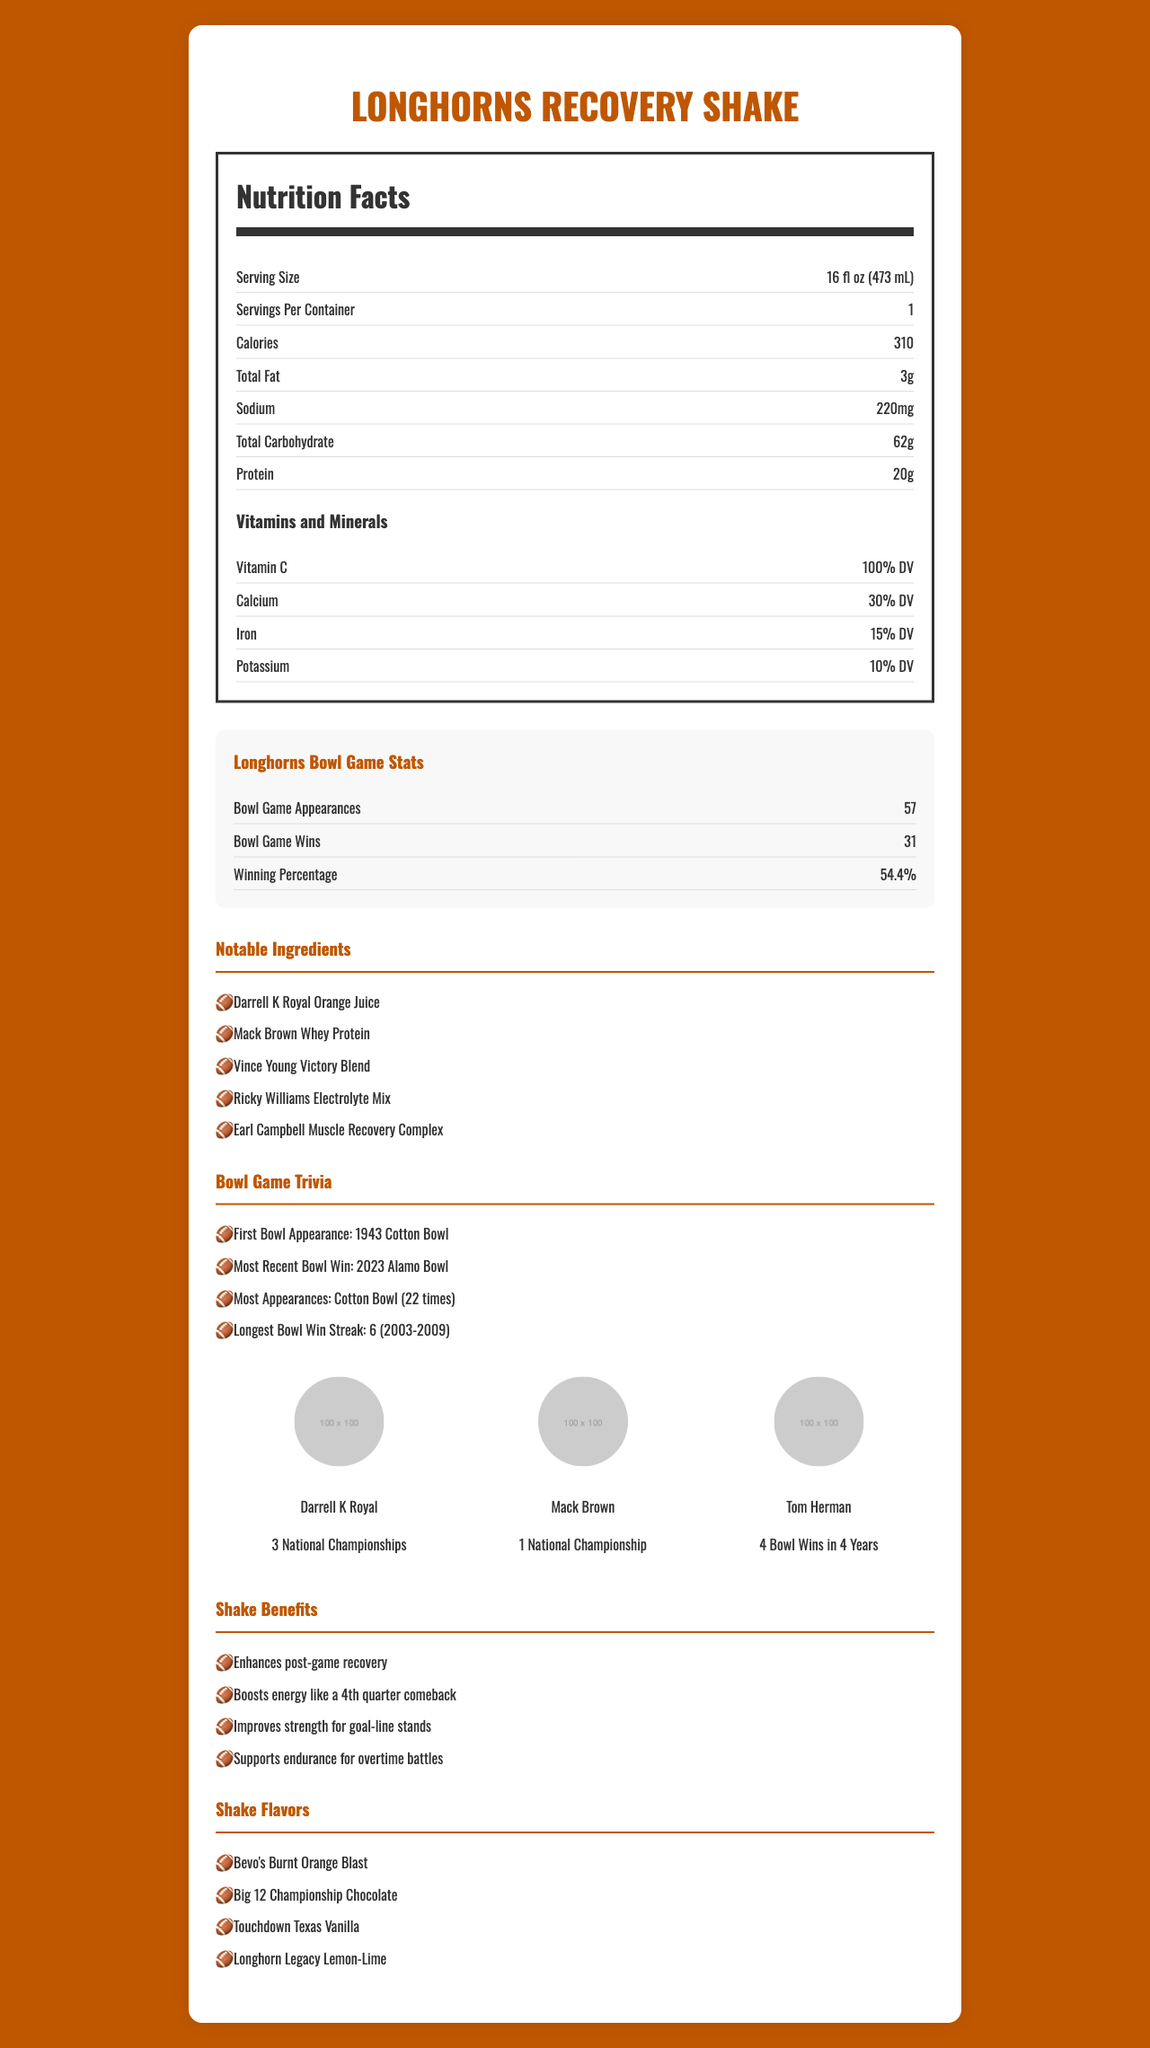what is the serving size? The serving size information is shown in the Nutrition Facts section near the top of the document.
Answer: 16 fl oz (473 mL) how many calories are in a serving of the shake? The calorie count is listed in the Nutrition Facts section under the serving size information.
Answer: 310 what is the amount of protein per serving? The amount of protein is listed in the Nutrition Facts section under the calories.
Answer: 20g what percentage of the daily value (DV) of Vitamin C does this shake provide? The percentage of Vitamin C is listed under the Vitamins and Minerals section in the Nutrition Facts.
Answer: 100% DV how many bowl game appearances have the Longhorns made? The number of bowl game appearances is stated in the Longhorns Bowl Game Stats section.
Answer: 57 which coach has the most national championships with the Longhorns? A. Mack Brown B. Darrell K Royal C. Tom Herman The Coaching Legends section lists Darrell K Royal with 3 National Championships, more than the others.
Answer: B what flavor options are available for the Longhorns Recovery Shake? A. Bevo's Burnt Orange Blast B. Championship Strawberry C. Big 12 Championship Chocolate D. Touchdown Texas Vanilla The Shake Flavors section lists Bevo's Burnt Orange Blast, Big 12 Championship Chocolate, Touchdown Texas Vanilla, and Longhorn Legacy Lemon-Lime.
Answer: A, C, D what was the Longhorns' most recent bowl win as noted in the document? The Bowl Game Trivia section mentions the most recent bowl win as the 2023 Alamo Bowl.
Answer: 2023 Alamo Bowl does the shake contain Darrell K Royal Orange Juice? The Notable Ingredients section lists Darrell K Royal Orange Juice as an ingredient.
Answer: Yes describe the main idea of the document. The explanation covers all major sections and themes present in the document.
Answer: The document provides detailed nutrition facts for the Longhorns Recovery Shake, including serving size, calories, fat, sodium, carbohydrates, protein, and key vitamins and minerals. Additionally, it highlights Longhorns' historic football achievements like bowl game appearances and wins, notable ingredients named after legendary players and coaches, bowl game trivia, coaching legends, benefits of the shake, and flavor options. when was the Longhorns' first bowl appearance? This information is stated in the Bowl Game Trivia section.
Answer: 1943 Cotton Bowl do they provide information on the number of carbs per serving? The Total Carbohydrate is mentioned as 62g in the Nutrition Facts section.
Answer: Yes how does the shake help post-game recovery? The Shake Benefits section lists enhancing post-game recovery as one of the shake's benefits.
Answer: Enhances post-game recovery who is better, the Longhorns or the Aggies? The document does not contain any information comparing the Longhorns with the Aggies.
Answer: Cannot be determined what is the sodium content in a serving? The sodium content is listed in the Nutrition Facts section as 220mg.
Answer: 220mg what is the winning percentage of the Longhorns in bowl games? The winning percentage is listed in the Longhorns Bowl Game Stats section.
Answer: 54.4% what benefits does the shake claim to provide? All these benefits are listed in the Shake Benefits section.
Answer: Enhances post-game recovery, boosts energy like a 4th quarter comeback, improves strength for goal-line stands, supports endurance for overtime battles 